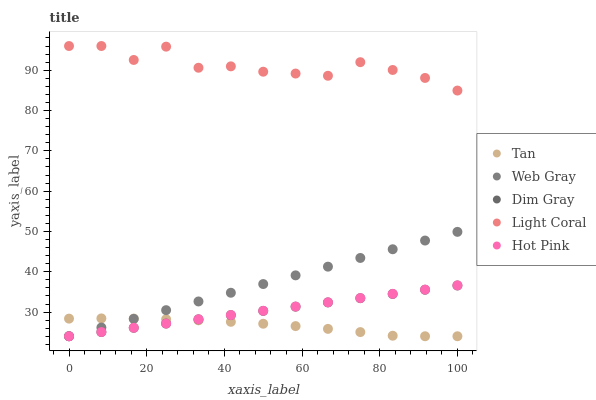Does Tan have the minimum area under the curve?
Answer yes or no. Yes. Does Light Coral have the maximum area under the curve?
Answer yes or no. Yes. Does Web Gray have the minimum area under the curve?
Answer yes or no. No. Does Web Gray have the maximum area under the curve?
Answer yes or no. No. Is Dim Gray the smoothest?
Answer yes or no. Yes. Is Light Coral the roughest?
Answer yes or no. Yes. Is Tan the smoothest?
Answer yes or no. No. Is Tan the roughest?
Answer yes or no. No. Does Tan have the lowest value?
Answer yes or no. Yes. Does Light Coral have the highest value?
Answer yes or no. Yes. Does Web Gray have the highest value?
Answer yes or no. No. Is Hot Pink less than Light Coral?
Answer yes or no. Yes. Is Light Coral greater than Tan?
Answer yes or no. Yes. Does Tan intersect Hot Pink?
Answer yes or no. Yes. Is Tan less than Hot Pink?
Answer yes or no. No. Is Tan greater than Hot Pink?
Answer yes or no. No. Does Hot Pink intersect Light Coral?
Answer yes or no. No. 